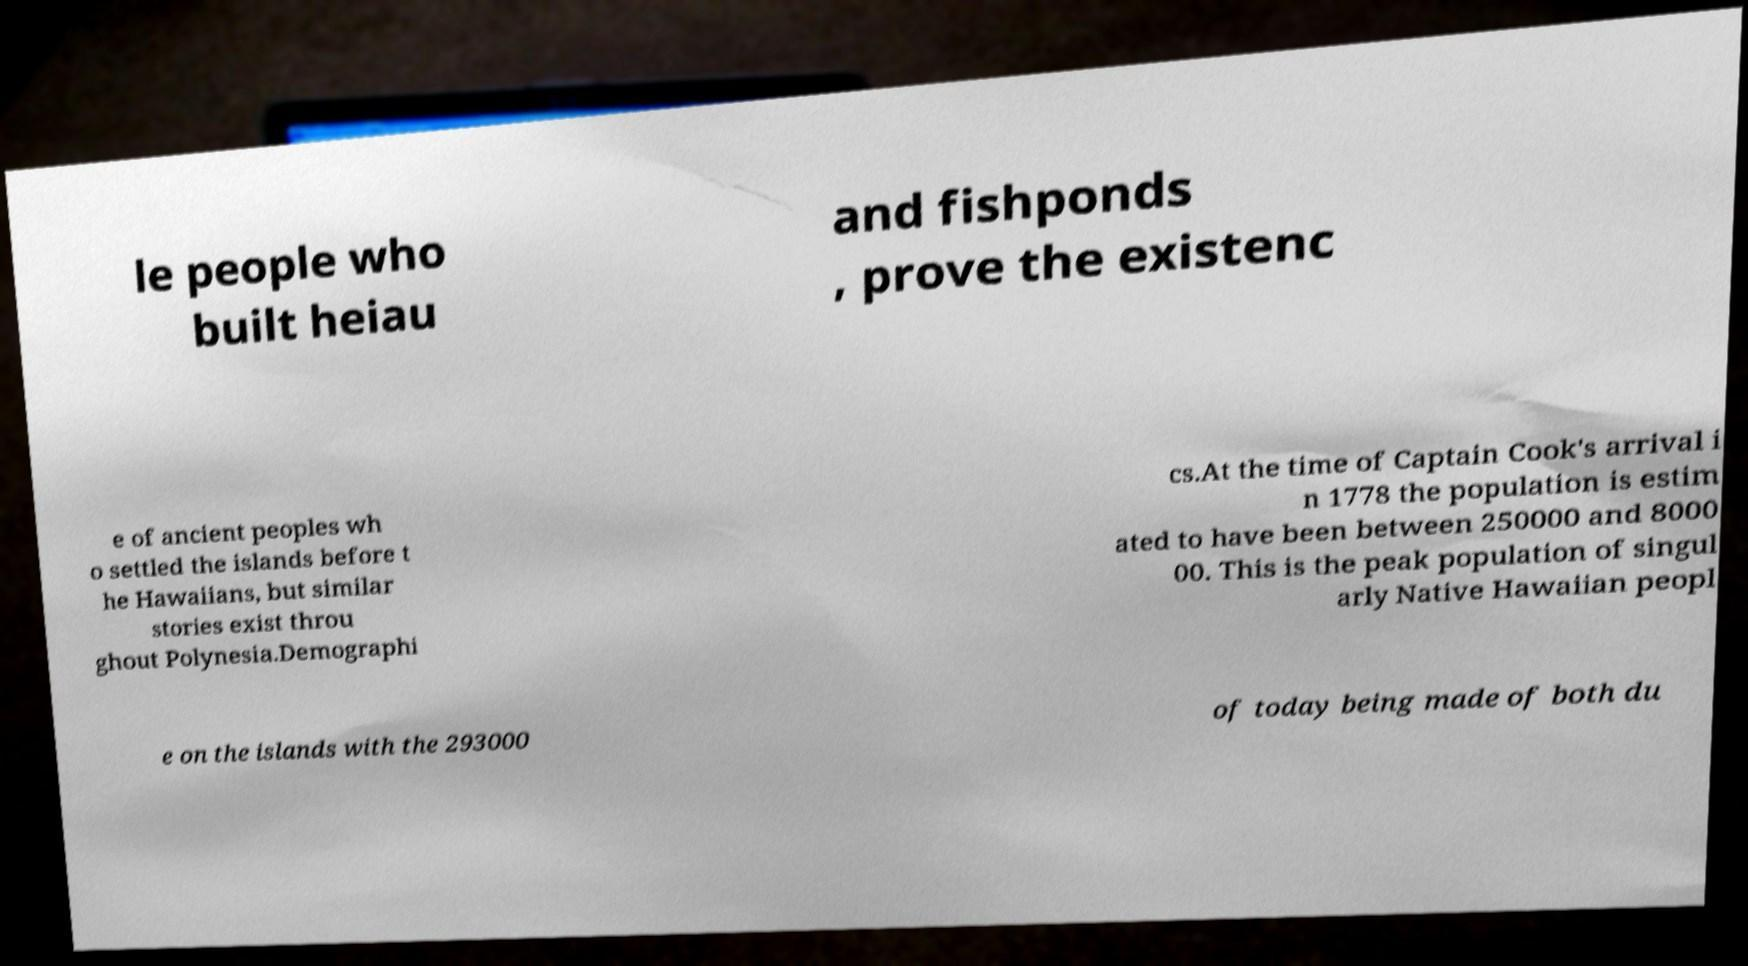I need the written content from this picture converted into text. Can you do that? le people who built heiau and fishponds , prove the existenc e of ancient peoples wh o settled the islands before t he Hawaiians, but similar stories exist throu ghout Polynesia.Demographi cs.At the time of Captain Cook's arrival i n 1778 the population is estim ated to have been between 250000 and 8000 00. This is the peak population of singul arly Native Hawaiian peopl e on the islands with the 293000 of today being made of both du 